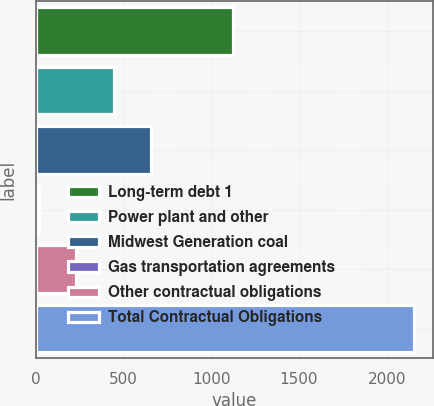<chart> <loc_0><loc_0><loc_500><loc_500><bar_chart><fcel>Long-term debt 1<fcel>Power plant and other<fcel>Midwest Generation coal<fcel>Gas transportation agreements<fcel>Other contractual obligations<fcel>Total Contractual Obligations<nl><fcel>1123<fcel>443.2<fcel>657.3<fcel>15<fcel>229.1<fcel>2156<nl></chart> 